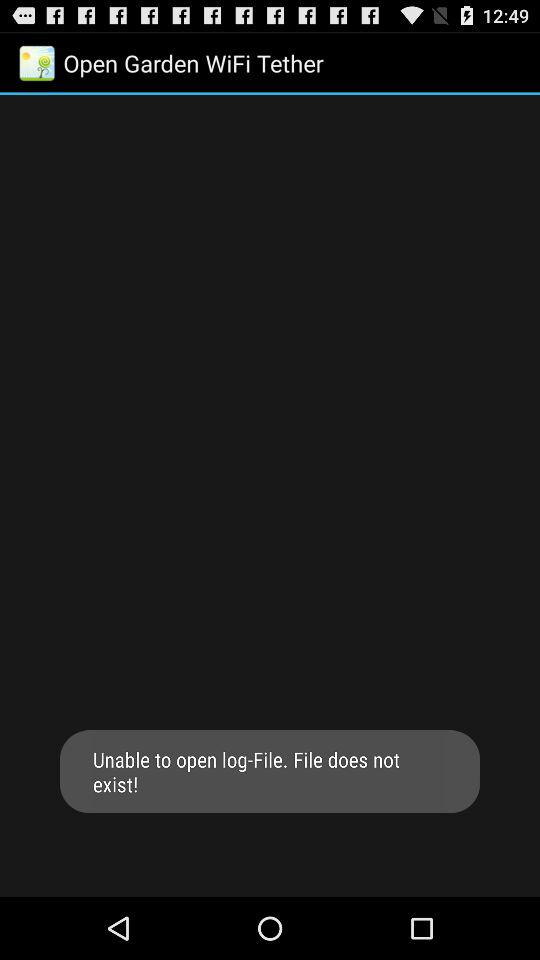What is the application name? The application name is "Open Garden WiFi Tether". 